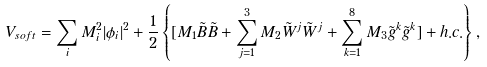<formula> <loc_0><loc_0><loc_500><loc_500>V _ { s o f t } = \sum _ { i } M _ { i } ^ { 2 } | \phi _ { i } | ^ { 2 } + \frac { 1 } { 2 } \left \{ [ M _ { 1 } \tilde { B } \tilde { B } + \sum _ { j = 1 } ^ { 3 } M _ { 2 } \tilde { W } ^ { j } \tilde { W } ^ { j } + \sum _ { k = 1 } ^ { 8 } M _ { 3 } \tilde { g } ^ { k } \tilde { g } ^ { k } ] + h . c . \right \} ,</formula> 